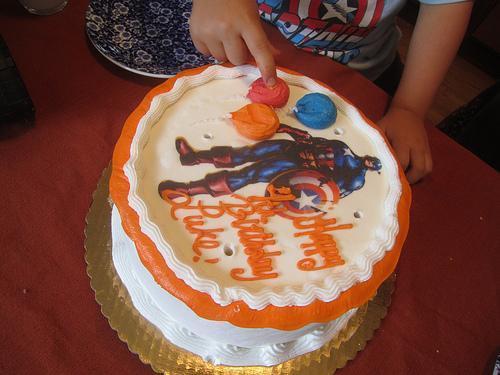How many cake are there?
Give a very brief answer. 1. 